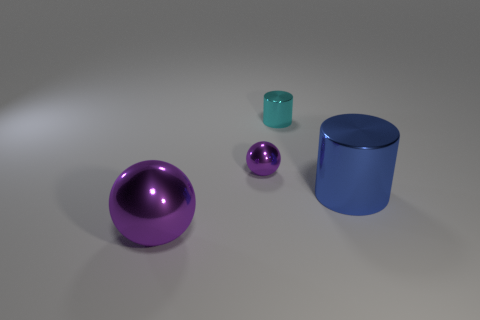Add 1 small purple things. How many objects exist? 5 Subtract all purple metal spheres. Subtract all large purple shiny balls. How many objects are left? 1 Add 1 small purple metallic things. How many small purple metallic things are left? 2 Add 1 big brown blocks. How many big brown blocks exist? 1 Subtract 0 red cubes. How many objects are left? 4 